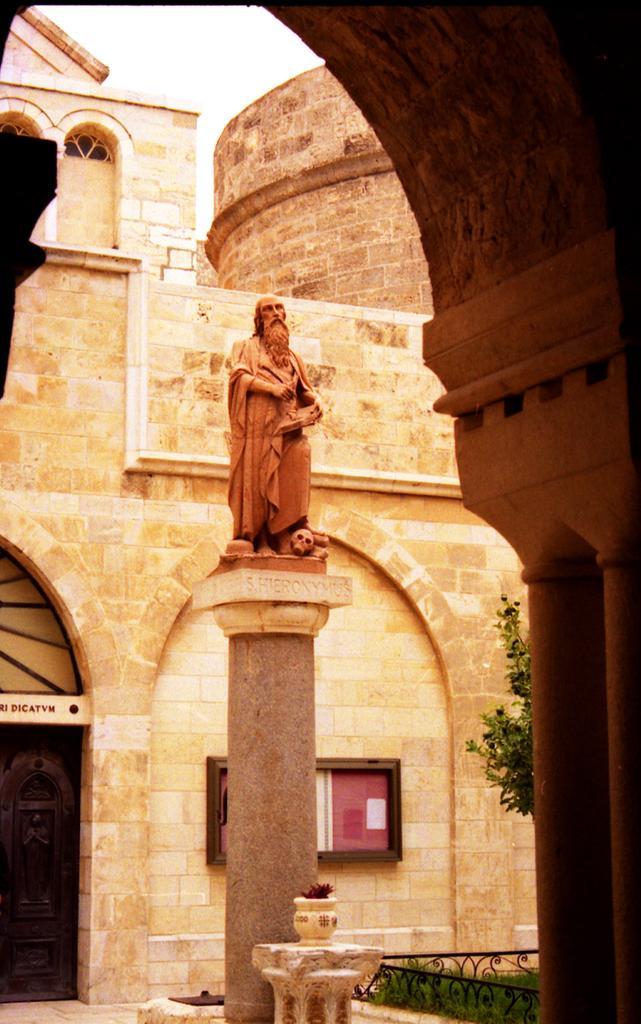Could you give a brief overview of what you see in this image? In the image we can see a sculpture standing and wearing clothes. We can see a stone building, pillar, grass, plant and the sky. Here we can see the arch and the board. 